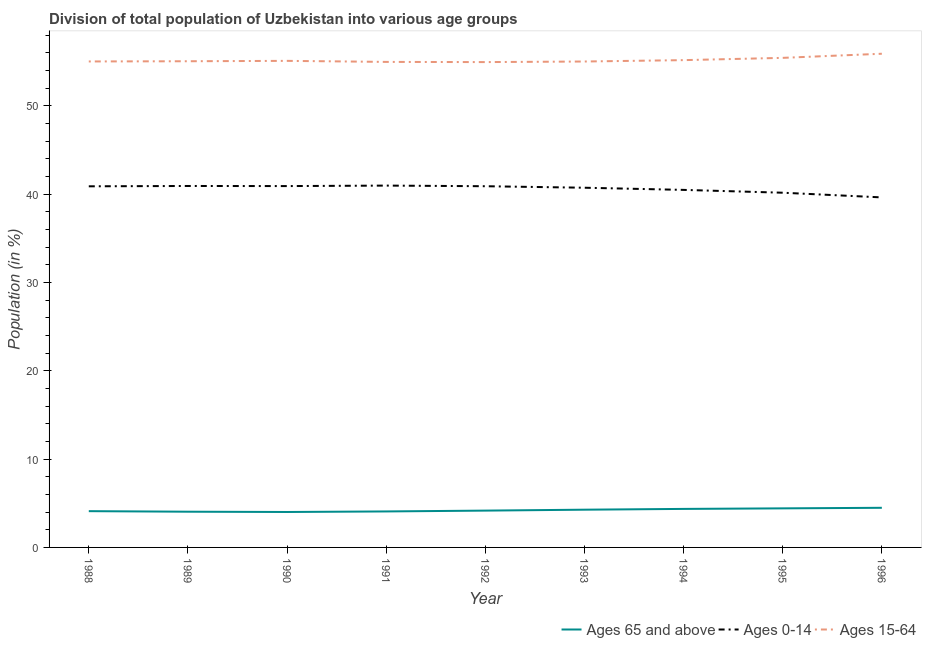Is the number of lines equal to the number of legend labels?
Make the answer very short. Yes. What is the percentage of population within the age-group 15-64 in 1994?
Give a very brief answer. 55.16. Across all years, what is the maximum percentage of population within the age-group of 65 and above?
Offer a very short reply. 4.49. Across all years, what is the minimum percentage of population within the age-group 15-64?
Your response must be concise. 54.94. What is the total percentage of population within the age-group of 65 and above in the graph?
Make the answer very short. 37.95. What is the difference between the percentage of population within the age-group of 65 and above in 1993 and that in 1995?
Offer a very short reply. -0.15. What is the difference between the percentage of population within the age-group 0-14 in 1994 and the percentage of population within the age-group of 65 and above in 1993?
Make the answer very short. 36.2. What is the average percentage of population within the age-group 0-14 per year?
Provide a succinct answer. 40.61. In the year 1988, what is the difference between the percentage of population within the age-group 0-14 and percentage of population within the age-group of 65 and above?
Ensure brevity in your answer.  36.77. What is the ratio of the percentage of population within the age-group 15-64 in 1990 to that in 1992?
Your response must be concise. 1. Is the percentage of population within the age-group 15-64 in 1992 less than that in 1995?
Your response must be concise. Yes. Is the difference between the percentage of population within the age-group 0-14 in 1989 and 1990 greater than the difference between the percentage of population within the age-group 15-64 in 1989 and 1990?
Your answer should be very brief. Yes. What is the difference between the highest and the second highest percentage of population within the age-group 15-64?
Give a very brief answer. 0.47. What is the difference between the highest and the lowest percentage of population within the age-group of 65 and above?
Keep it short and to the point. 0.48. In how many years, is the percentage of population within the age-group 0-14 greater than the average percentage of population within the age-group 0-14 taken over all years?
Keep it short and to the point. 6. Is the sum of the percentage of population within the age-group 0-14 in 1988 and 1990 greater than the maximum percentage of population within the age-group 15-64 across all years?
Your answer should be very brief. Yes. Does the percentage of population within the age-group 15-64 monotonically increase over the years?
Provide a short and direct response. No. Is the percentage of population within the age-group 15-64 strictly less than the percentage of population within the age-group 0-14 over the years?
Your response must be concise. No. How many years are there in the graph?
Offer a terse response. 9. What is the difference between two consecutive major ticks on the Y-axis?
Make the answer very short. 10. Are the values on the major ticks of Y-axis written in scientific E-notation?
Offer a terse response. No. Does the graph contain grids?
Your answer should be compact. No. Where does the legend appear in the graph?
Offer a very short reply. Bottom right. How many legend labels are there?
Keep it short and to the point. 3. How are the legend labels stacked?
Give a very brief answer. Horizontal. What is the title of the graph?
Ensure brevity in your answer.  Division of total population of Uzbekistan into various age groups
. What is the Population (in %) in Ages 65 and above in 1988?
Your answer should be compact. 4.11. What is the Population (in %) of Ages 0-14 in 1988?
Offer a terse response. 40.88. What is the Population (in %) in Ages 15-64 in 1988?
Your response must be concise. 55.01. What is the Population (in %) of Ages 65 and above in 1989?
Give a very brief answer. 4.04. What is the Population (in %) in Ages 0-14 in 1989?
Give a very brief answer. 40.92. What is the Population (in %) of Ages 15-64 in 1989?
Provide a succinct answer. 55.04. What is the Population (in %) of Ages 65 and above in 1990?
Your response must be concise. 4.01. What is the Population (in %) in Ages 0-14 in 1990?
Give a very brief answer. 40.91. What is the Population (in %) in Ages 15-64 in 1990?
Your response must be concise. 55.08. What is the Population (in %) of Ages 65 and above in 1991?
Your answer should be compact. 4.07. What is the Population (in %) of Ages 0-14 in 1991?
Keep it short and to the point. 40.96. What is the Population (in %) of Ages 15-64 in 1991?
Provide a short and direct response. 54.96. What is the Population (in %) of Ages 65 and above in 1992?
Offer a very short reply. 4.17. What is the Population (in %) in Ages 0-14 in 1992?
Make the answer very short. 40.89. What is the Population (in %) of Ages 15-64 in 1992?
Provide a succinct answer. 54.94. What is the Population (in %) in Ages 65 and above in 1993?
Offer a terse response. 4.27. What is the Population (in %) in Ages 0-14 in 1993?
Your answer should be compact. 40.72. What is the Population (in %) of Ages 15-64 in 1993?
Offer a very short reply. 55.01. What is the Population (in %) in Ages 65 and above in 1994?
Keep it short and to the point. 4.36. What is the Population (in %) of Ages 0-14 in 1994?
Your answer should be compact. 40.47. What is the Population (in %) in Ages 15-64 in 1994?
Keep it short and to the point. 55.16. What is the Population (in %) of Ages 65 and above in 1995?
Your answer should be compact. 4.42. What is the Population (in %) in Ages 0-14 in 1995?
Ensure brevity in your answer.  40.16. What is the Population (in %) of Ages 15-64 in 1995?
Provide a succinct answer. 55.42. What is the Population (in %) in Ages 65 and above in 1996?
Give a very brief answer. 4.49. What is the Population (in %) in Ages 0-14 in 1996?
Offer a very short reply. 39.62. What is the Population (in %) in Ages 15-64 in 1996?
Keep it short and to the point. 55.89. Across all years, what is the maximum Population (in %) of Ages 65 and above?
Your answer should be compact. 4.49. Across all years, what is the maximum Population (in %) in Ages 0-14?
Your response must be concise. 40.96. Across all years, what is the maximum Population (in %) in Ages 15-64?
Offer a terse response. 55.89. Across all years, what is the minimum Population (in %) of Ages 65 and above?
Keep it short and to the point. 4.01. Across all years, what is the minimum Population (in %) in Ages 0-14?
Offer a terse response. 39.62. Across all years, what is the minimum Population (in %) in Ages 15-64?
Your answer should be compact. 54.94. What is the total Population (in %) of Ages 65 and above in the graph?
Your answer should be compact. 37.95. What is the total Population (in %) of Ages 0-14 in the graph?
Keep it short and to the point. 365.53. What is the total Population (in %) in Ages 15-64 in the graph?
Give a very brief answer. 496.52. What is the difference between the Population (in %) in Ages 65 and above in 1988 and that in 1989?
Ensure brevity in your answer.  0.06. What is the difference between the Population (in %) in Ages 0-14 in 1988 and that in 1989?
Offer a terse response. -0.04. What is the difference between the Population (in %) in Ages 15-64 in 1988 and that in 1989?
Keep it short and to the point. -0.02. What is the difference between the Population (in %) of Ages 65 and above in 1988 and that in 1990?
Your answer should be compact. 0.09. What is the difference between the Population (in %) in Ages 0-14 in 1988 and that in 1990?
Make the answer very short. -0.03. What is the difference between the Population (in %) of Ages 15-64 in 1988 and that in 1990?
Keep it short and to the point. -0.07. What is the difference between the Population (in %) in Ages 65 and above in 1988 and that in 1991?
Provide a succinct answer. 0.03. What is the difference between the Population (in %) in Ages 0-14 in 1988 and that in 1991?
Make the answer very short. -0.08. What is the difference between the Population (in %) in Ages 15-64 in 1988 and that in 1991?
Keep it short and to the point. 0.05. What is the difference between the Population (in %) in Ages 65 and above in 1988 and that in 1992?
Ensure brevity in your answer.  -0.06. What is the difference between the Population (in %) of Ages 0-14 in 1988 and that in 1992?
Keep it short and to the point. -0.01. What is the difference between the Population (in %) of Ages 15-64 in 1988 and that in 1992?
Provide a succinct answer. 0.07. What is the difference between the Population (in %) in Ages 65 and above in 1988 and that in 1993?
Keep it short and to the point. -0.17. What is the difference between the Population (in %) of Ages 0-14 in 1988 and that in 1993?
Ensure brevity in your answer.  0.16. What is the difference between the Population (in %) in Ages 15-64 in 1988 and that in 1993?
Provide a succinct answer. 0.01. What is the difference between the Population (in %) in Ages 65 and above in 1988 and that in 1994?
Offer a very short reply. -0.26. What is the difference between the Population (in %) of Ages 0-14 in 1988 and that in 1994?
Make the answer very short. 0.41. What is the difference between the Population (in %) of Ages 15-64 in 1988 and that in 1994?
Keep it short and to the point. -0.15. What is the difference between the Population (in %) in Ages 65 and above in 1988 and that in 1995?
Your answer should be very brief. -0.32. What is the difference between the Population (in %) of Ages 0-14 in 1988 and that in 1995?
Make the answer very short. 0.73. What is the difference between the Population (in %) of Ages 15-64 in 1988 and that in 1995?
Make the answer very short. -0.41. What is the difference between the Population (in %) of Ages 65 and above in 1988 and that in 1996?
Offer a very short reply. -0.38. What is the difference between the Population (in %) of Ages 0-14 in 1988 and that in 1996?
Provide a succinct answer. 1.26. What is the difference between the Population (in %) of Ages 15-64 in 1988 and that in 1996?
Ensure brevity in your answer.  -0.87. What is the difference between the Population (in %) of Ages 65 and above in 1989 and that in 1990?
Ensure brevity in your answer.  0.03. What is the difference between the Population (in %) in Ages 0-14 in 1989 and that in 1990?
Provide a short and direct response. 0.01. What is the difference between the Population (in %) in Ages 15-64 in 1989 and that in 1990?
Keep it short and to the point. -0.04. What is the difference between the Population (in %) in Ages 65 and above in 1989 and that in 1991?
Make the answer very short. -0.03. What is the difference between the Population (in %) in Ages 0-14 in 1989 and that in 1991?
Keep it short and to the point. -0.04. What is the difference between the Population (in %) of Ages 15-64 in 1989 and that in 1991?
Keep it short and to the point. 0.07. What is the difference between the Population (in %) in Ages 65 and above in 1989 and that in 1992?
Provide a succinct answer. -0.12. What is the difference between the Population (in %) of Ages 0-14 in 1989 and that in 1992?
Make the answer very short. 0.03. What is the difference between the Population (in %) of Ages 15-64 in 1989 and that in 1992?
Provide a short and direct response. 0.1. What is the difference between the Population (in %) in Ages 65 and above in 1989 and that in 1993?
Keep it short and to the point. -0.23. What is the difference between the Population (in %) of Ages 0-14 in 1989 and that in 1993?
Offer a very short reply. 0.2. What is the difference between the Population (in %) of Ages 15-64 in 1989 and that in 1993?
Your answer should be compact. 0.03. What is the difference between the Population (in %) in Ages 65 and above in 1989 and that in 1994?
Provide a short and direct response. -0.32. What is the difference between the Population (in %) in Ages 0-14 in 1989 and that in 1994?
Give a very brief answer. 0.44. What is the difference between the Population (in %) of Ages 15-64 in 1989 and that in 1994?
Your answer should be very brief. -0.13. What is the difference between the Population (in %) in Ages 65 and above in 1989 and that in 1995?
Keep it short and to the point. -0.38. What is the difference between the Population (in %) of Ages 0-14 in 1989 and that in 1995?
Provide a succinct answer. 0.76. What is the difference between the Population (in %) in Ages 15-64 in 1989 and that in 1995?
Give a very brief answer. -0.38. What is the difference between the Population (in %) of Ages 65 and above in 1989 and that in 1996?
Your answer should be compact. -0.44. What is the difference between the Population (in %) of Ages 0-14 in 1989 and that in 1996?
Your response must be concise. 1.29. What is the difference between the Population (in %) in Ages 15-64 in 1989 and that in 1996?
Make the answer very short. -0.85. What is the difference between the Population (in %) of Ages 65 and above in 1990 and that in 1991?
Offer a terse response. -0.06. What is the difference between the Population (in %) of Ages 0-14 in 1990 and that in 1991?
Offer a terse response. -0.06. What is the difference between the Population (in %) of Ages 15-64 in 1990 and that in 1991?
Your answer should be very brief. 0.12. What is the difference between the Population (in %) in Ages 65 and above in 1990 and that in 1992?
Offer a terse response. -0.16. What is the difference between the Population (in %) of Ages 0-14 in 1990 and that in 1992?
Provide a short and direct response. 0.02. What is the difference between the Population (in %) of Ages 15-64 in 1990 and that in 1992?
Make the answer very short. 0.14. What is the difference between the Population (in %) in Ages 65 and above in 1990 and that in 1993?
Your response must be concise. -0.26. What is the difference between the Population (in %) of Ages 0-14 in 1990 and that in 1993?
Provide a short and direct response. 0.19. What is the difference between the Population (in %) of Ages 15-64 in 1990 and that in 1993?
Your response must be concise. 0.07. What is the difference between the Population (in %) in Ages 65 and above in 1990 and that in 1994?
Ensure brevity in your answer.  -0.35. What is the difference between the Population (in %) in Ages 0-14 in 1990 and that in 1994?
Give a very brief answer. 0.43. What is the difference between the Population (in %) of Ages 15-64 in 1990 and that in 1994?
Ensure brevity in your answer.  -0.08. What is the difference between the Population (in %) of Ages 65 and above in 1990 and that in 1995?
Keep it short and to the point. -0.41. What is the difference between the Population (in %) of Ages 0-14 in 1990 and that in 1995?
Give a very brief answer. 0.75. What is the difference between the Population (in %) of Ages 15-64 in 1990 and that in 1995?
Ensure brevity in your answer.  -0.34. What is the difference between the Population (in %) of Ages 65 and above in 1990 and that in 1996?
Provide a succinct answer. -0.48. What is the difference between the Population (in %) of Ages 0-14 in 1990 and that in 1996?
Keep it short and to the point. 1.28. What is the difference between the Population (in %) in Ages 15-64 in 1990 and that in 1996?
Provide a short and direct response. -0.81. What is the difference between the Population (in %) of Ages 65 and above in 1991 and that in 1992?
Your answer should be compact. -0.09. What is the difference between the Population (in %) of Ages 0-14 in 1991 and that in 1992?
Your answer should be compact. 0.07. What is the difference between the Population (in %) in Ages 15-64 in 1991 and that in 1992?
Your response must be concise. 0.02. What is the difference between the Population (in %) of Ages 65 and above in 1991 and that in 1993?
Offer a very short reply. -0.2. What is the difference between the Population (in %) in Ages 0-14 in 1991 and that in 1993?
Your answer should be very brief. 0.24. What is the difference between the Population (in %) of Ages 15-64 in 1991 and that in 1993?
Provide a succinct answer. -0.05. What is the difference between the Population (in %) in Ages 65 and above in 1991 and that in 1994?
Your answer should be compact. -0.29. What is the difference between the Population (in %) of Ages 0-14 in 1991 and that in 1994?
Ensure brevity in your answer.  0.49. What is the difference between the Population (in %) in Ages 15-64 in 1991 and that in 1994?
Offer a terse response. -0.2. What is the difference between the Population (in %) in Ages 65 and above in 1991 and that in 1995?
Ensure brevity in your answer.  -0.35. What is the difference between the Population (in %) in Ages 0-14 in 1991 and that in 1995?
Your response must be concise. 0.81. What is the difference between the Population (in %) in Ages 15-64 in 1991 and that in 1995?
Ensure brevity in your answer.  -0.46. What is the difference between the Population (in %) of Ages 65 and above in 1991 and that in 1996?
Ensure brevity in your answer.  -0.41. What is the difference between the Population (in %) in Ages 0-14 in 1991 and that in 1996?
Your response must be concise. 1.34. What is the difference between the Population (in %) of Ages 15-64 in 1991 and that in 1996?
Provide a succinct answer. -0.92. What is the difference between the Population (in %) of Ages 65 and above in 1992 and that in 1993?
Ensure brevity in your answer.  -0.1. What is the difference between the Population (in %) in Ages 0-14 in 1992 and that in 1993?
Your answer should be compact. 0.17. What is the difference between the Population (in %) in Ages 15-64 in 1992 and that in 1993?
Provide a succinct answer. -0.07. What is the difference between the Population (in %) in Ages 65 and above in 1992 and that in 1994?
Your response must be concise. -0.19. What is the difference between the Population (in %) of Ages 0-14 in 1992 and that in 1994?
Give a very brief answer. 0.42. What is the difference between the Population (in %) in Ages 15-64 in 1992 and that in 1994?
Keep it short and to the point. -0.22. What is the difference between the Population (in %) of Ages 65 and above in 1992 and that in 1995?
Make the answer very short. -0.26. What is the difference between the Population (in %) in Ages 0-14 in 1992 and that in 1995?
Ensure brevity in your answer.  0.73. What is the difference between the Population (in %) of Ages 15-64 in 1992 and that in 1995?
Your response must be concise. -0.48. What is the difference between the Population (in %) of Ages 65 and above in 1992 and that in 1996?
Offer a very short reply. -0.32. What is the difference between the Population (in %) in Ages 0-14 in 1992 and that in 1996?
Your answer should be very brief. 1.27. What is the difference between the Population (in %) in Ages 15-64 in 1992 and that in 1996?
Your answer should be compact. -0.95. What is the difference between the Population (in %) of Ages 65 and above in 1993 and that in 1994?
Provide a succinct answer. -0.09. What is the difference between the Population (in %) in Ages 0-14 in 1993 and that in 1994?
Ensure brevity in your answer.  0.24. What is the difference between the Population (in %) of Ages 15-64 in 1993 and that in 1994?
Offer a very short reply. -0.16. What is the difference between the Population (in %) of Ages 65 and above in 1993 and that in 1995?
Make the answer very short. -0.15. What is the difference between the Population (in %) in Ages 0-14 in 1993 and that in 1995?
Offer a terse response. 0.56. What is the difference between the Population (in %) in Ages 15-64 in 1993 and that in 1995?
Ensure brevity in your answer.  -0.41. What is the difference between the Population (in %) of Ages 65 and above in 1993 and that in 1996?
Make the answer very short. -0.22. What is the difference between the Population (in %) in Ages 0-14 in 1993 and that in 1996?
Give a very brief answer. 1.09. What is the difference between the Population (in %) of Ages 15-64 in 1993 and that in 1996?
Provide a succinct answer. -0.88. What is the difference between the Population (in %) in Ages 65 and above in 1994 and that in 1995?
Your response must be concise. -0.06. What is the difference between the Population (in %) of Ages 0-14 in 1994 and that in 1995?
Your answer should be compact. 0.32. What is the difference between the Population (in %) in Ages 15-64 in 1994 and that in 1995?
Your answer should be very brief. -0.26. What is the difference between the Population (in %) of Ages 65 and above in 1994 and that in 1996?
Your response must be concise. -0.13. What is the difference between the Population (in %) in Ages 0-14 in 1994 and that in 1996?
Offer a terse response. 0.85. What is the difference between the Population (in %) of Ages 15-64 in 1994 and that in 1996?
Your response must be concise. -0.72. What is the difference between the Population (in %) of Ages 65 and above in 1995 and that in 1996?
Your answer should be compact. -0.06. What is the difference between the Population (in %) in Ages 0-14 in 1995 and that in 1996?
Provide a succinct answer. 0.53. What is the difference between the Population (in %) in Ages 15-64 in 1995 and that in 1996?
Your answer should be compact. -0.47. What is the difference between the Population (in %) in Ages 65 and above in 1988 and the Population (in %) in Ages 0-14 in 1989?
Your answer should be very brief. -36.81. What is the difference between the Population (in %) in Ages 65 and above in 1988 and the Population (in %) in Ages 15-64 in 1989?
Your answer should be compact. -50.93. What is the difference between the Population (in %) of Ages 0-14 in 1988 and the Population (in %) of Ages 15-64 in 1989?
Make the answer very short. -14.16. What is the difference between the Population (in %) of Ages 65 and above in 1988 and the Population (in %) of Ages 0-14 in 1990?
Ensure brevity in your answer.  -36.8. What is the difference between the Population (in %) of Ages 65 and above in 1988 and the Population (in %) of Ages 15-64 in 1990?
Your answer should be very brief. -50.98. What is the difference between the Population (in %) in Ages 0-14 in 1988 and the Population (in %) in Ages 15-64 in 1990?
Your response must be concise. -14.2. What is the difference between the Population (in %) of Ages 65 and above in 1988 and the Population (in %) of Ages 0-14 in 1991?
Make the answer very short. -36.86. What is the difference between the Population (in %) of Ages 65 and above in 1988 and the Population (in %) of Ages 15-64 in 1991?
Your response must be concise. -50.86. What is the difference between the Population (in %) in Ages 0-14 in 1988 and the Population (in %) in Ages 15-64 in 1991?
Give a very brief answer. -14.08. What is the difference between the Population (in %) of Ages 65 and above in 1988 and the Population (in %) of Ages 0-14 in 1992?
Your response must be concise. -36.78. What is the difference between the Population (in %) of Ages 65 and above in 1988 and the Population (in %) of Ages 15-64 in 1992?
Make the answer very short. -50.84. What is the difference between the Population (in %) in Ages 0-14 in 1988 and the Population (in %) in Ages 15-64 in 1992?
Ensure brevity in your answer.  -14.06. What is the difference between the Population (in %) of Ages 65 and above in 1988 and the Population (in %) of Ages 0-14 in 1993?
Your answer should be compact. -36.61. What is the difference between the Population (in %) in Ages 65 and above in 1988 and the Population (in %) in Ages 15-64 in 1993?
Offer a terse response. -50.9. What is the difference between the Population (in %) in Ages 0-14 in 1988 and the Population (in %) in Ages 15-64 in 1993?
Give a very brief answer. -14.13. What is the difference between the Population (in %) of Ages 65 and above in 1988 and the Population (in %) of Ages 0-14 in 1994?
Provide a succinct answer. -36.37. What is the difference between the Population (in %) in Ages 65 and above in 1988 and the Population (in %) in Ages 15-64 in 1994?
Ensure brevity in your answer.  -51.06. What is the difference between the Population (in %) of Ages 0-14 in 1988 and the Population (in %) of Ages 15-64 in 1994?
Make the answer very short. -14.28. What is the difference between the Population (in %) of Ages 65 and above in 1988 and the Population (in %) of Ages 0-14 in 1995?
Your answer should be compact. -36.05. What is the difference between the Population (in %) of Ages 65 and above in 1988 and the Population (in %) of Ages 15-64 in 1995?
Ensure brevity in your answer.  -51.32. What is the difference between the Population (in %) of Ages 0-14 in 1988 and the Population (in %) of Ages 15-64 in 1995?
Offer a terse response. -14.54. What is the difference between the Population (in %) in Ages 65 and above in 1988 and the Population (in %) in Ages 0-14 in 1996?
Your answer should be very brief. -35.52. What is the difference between the Population (in %) of Ages 65 and above in 1988 and the Population (in %) of Ages 15-64 in 1996?
Offer a very short reply. -51.78. What is the difference between the Population (in %) in Ages 0-14 in 1988 and the Population (in %) in Ages 15-64 in 1996?
Your answer should be very brief. -15.01. What is the difference between the Population (in %) in Ages 65 and above in 1989 and the Population (in %) in Ages 0-14 in 1990?
Ensure brevity in your answer.  -36.86. What is the difference between the Population (in %) in Ages 65 and above in 1989 and the Population (in %) in Ages 15-64 in 1990?
Provide a short and direct response. -51.04. What is the difference between the Population (in %) of Ages 0-14 in 1989 and the Population (in %) of Ages 15-64 in 1990?
Provide a succinct answer. -14.16. What is the difference between the Population (in %) of Ages 65 and above in 1989 and the Population (in %) of Ages 0-14 in 1991?
Give a very brief answer. -36.92. What is the difference between the Population (in %) in Ages 65 and above in 1989 and the Population (in %) in Ages 15-64 in 1991?
Give a very brief answer. -50.92. What is the difference between the Population (in %) in Ages 0-14 in 1989 and the Population (in %) in Ages 15-64 in 1991?
Keep it short and to the point. -14.05. What is the difference between the Population (in %) in Ages 65 and above in 1989 and the Population (in %) in Ages 0-14 in 1992?
Provide a short and direct response. -36.85. What is the difference between the Population (in %) of Ages 65 and above in 1989 and the Population (in %) of Ages 15-64 in 1992?
Your response must be concise. -50.9. What is the difference between the Population (in %) in Ages 0-14 in 1989 and the Population (in %) in Ages 15-64 in 1992?
Offer a terse response. -14.02. What is the difference between the Population (in %) of Ages 65 and above in 1989 and the Population (in %) of Ages 0-14 in 1993?
Your answer should be compact. -36.68. What is the difference between the Population (in %) in Ages 65 and above in 1989 and the Population (in %) in Ages 15-64 in 1993?
Keep it short and to the point. -50.97. What is the difference between the Population (in %) of Ages 0-14 in 1989 and the Population (in %) of Ages 15-64 in 1993?
Offer a terse response. -14.09. What is the difference between the Population (in %) in Ages 65 and above in 1989 and the Population (in %) in Ages 0-14 in 1994?
Provide a short and direct response. -36.43. What is the difference between the Population (in %) in Ages 65 and above in 1989 and the Population (in %) in Ages 15-64 in 1994?
Keep it short and to the point. -51.12. What is the difference between the Population (in %) of Ages 0-14 in 1989 and the Population (in %) of Ages 15-64 in 1994?
Keep it short and to the point. -14.25. What is the difference between the Population (in %) of Ages 65 and above in 1989 and the Population (in %) of Ages 0-14 in 1995?
Provide a succinct answer. -36.11. What is the difference between the Population (in %) in Ages 65 and above in 1989 and the Population (in %) in Ages 15-64 in 1995?
Give a very brief answer. -51.38. What is the difference between the Population (in %) in Ages 0-14 in 1989 and the Population (in %) in Ages 15-64 in 1995?
Keep it short and to the point. -14.5. What is the difference between the Population (in %) of Ages 65 and above in 1989 and the Population (in %) of Ages 0-14 in 1996?
Your answer should be compact. -35.58. What is the difference between the Population (in %) of Ages 65 and above in 1989 and the Population (in %) of Ages 15-64 in 1996?
Keep it short and to the point. -51.84. What is the difference between the Population (in %) in Ages 0-14 in 1989 and the Population (in %) in Ages 15-64 in 1996?
Provide a succinct answer. -14.97. What is the difference between the Population (in %) of Ages 65 and above in 1990 and the Population (in %) of Ages 0-14 in 1991?
Provide a succinct answer. -36.95. What is the difference between the Population (in %) of Ages 65 and above in 1990 and the Population (in %) of Ages 15-64 in 1991?
Keep it short and to the point. -50.95. What is the difference between the Population (in %) in Ages 0-14 in 1990 and the Population (in %) in Ages 15-64 in 1991?
Give a very brief answer. -14.06. What is the difference between the Population (in %) of Ages 65 and above in 1990 and the Population (in %) of Ages 0-14 in 1992?
Keep it short and to the point. -36.88. What is the difference between the Population (in %) of Ages 65 and above in 1990 and the Population (in %) of Ages 15-64 in 1992?
Give a very brief answer. -50.93. What is the difference between the Population (in %) of Ages 0-14 in 1990 and the Population (in %) of Ages 15-64 in 1992?
Your response must be concise. -14.04. What is the difference between the Population (in %) in Ages 65 and above in 1990 and the Population (in %) in Ages 0-14 in 1993?
Keep it short and to the point. -36.71. What is the difference between the Population (in %) of Ages 65 and above in 1990 and the Population (in %) of Ages 15-64 in 1993?
Your response must be concise. -51. What is the difference between the Population (in %) of Ages 0-14 in 1990 and the Population (in %) of Ages 15-64 in 1993?
Your response must be concise. -14.1. What is the difference between the Population (in %) of Ages 65 and above in 1990 and the Population (in %) of Ages 0-14 in 1994?
Keep it short and to the point. -36.46. What is the difference between the Population (in %) of Ages 65 and above in 1990 and the Population (in %) of Ages 15-64 in 1994?
Make the answer very short. -51.15. What is the difference between the Population (in %) of Ages 0-14 in 1990 and the Population (in %) of Ages 15-64 in 1994?
Keep it short and to the point. -14.26. What is the difference between the Population (in %) of Ages 65 and above in 1990 and the Population (in %) of Ages 0-14 in 1995?
Your answer should be very brief. -36.14. What is the difference between the Population (in %) of Ages 65 and above in 1990 and the Population (in %) of Ages 15-64 in 1995?
Ensure brevity in your answer.  -51.41. What is the difference between the Population (in %) of Ages 0-14 in 1990 and the Population (in %) of Ages 15-64 in 1995?
Provide a short and direct response. -14.52. What is the difference between the Population (in %) of Ages 65 and above in 1990 and the Population (in %) of Ages 0-14 in 1996?
Your answer should be compact. -35.61. What is the difference between the Population (in %) of Ages 65 and above in 1990 and the Population (in %) of Ages 15-64 in 1996?
Your answer should be compact. -51.88. What is the difference between the Population (in %) of Ages 0-14 in 1990 and the Population (in %) of Ages 15-64 in 1996?
Provide a succinct answer. -14.98. What is the difference between the Population (in %) in Ages 65 and above in 1991 and the Population (in %) in Ages 0-14 in 1992?
Provide a short and direct response. -36.82. What is the difference between the Population (in %) in Ages 65 and above in 1991 and the Population (in %) in Ages 15-64 in 1992?
Keep it short and to the point. -50.87. What is the difference between the Population (in %) of Ages 0-14 in 1991 and the Population (in %) of Ages 15-64 in 1992?
Keep it short and to the point. -13.98. What is the difference between the Population (in %) of Ages 65 and above in 1991 and the Population (in %) of Ages 0-14 in 1993?
Give a very brief answer. -36.65. What is the difference between the Population (in %) in Ages 65 and above in 1991 and the Population (in %) in Ages 15-64 in 1993?
Keep it short and to the point. -50.93. What is the difference between the Population (in %) in Ages 0-14 in 1991 and the Population (in %) in Ages 15-64 in 1993?
Offer a very short reply. -14.05. What is the difference between the Population (in %) of Ages 65 and above in 1991 and the Population (in %) of Ages 0-14 in 1994?
Offer a very short reply. -36.4. What is the difference between the Population (in %) of Ages 65 and above in 1991 and the Population (in %) of Ages 15-64 in 1994?
Keep it short and to the point. -51.09. What is the difference between the Population (in %) in Ages 0-14 in 1991 and the Population (in %) in Ages 15-64 in 1994?
Keep it short and to the point. -14.2. What is the difference between the Population (in %) of Ages 65 and above in 1991 and the Population (in %) of Ages 0-14 in 1995?
Provide a short and direct response. -36.08. What is the difference between the Population (in %) in Ages 65 and above in 1991 and the Population (in %) in Ages 15-64 in 1995?
Provide a short and direct response. -51.35. What is the difference between the Population (in %) in Ages 0-14 in 1991 and the Population (in %) in Ages 15-64 in 1995?
Your answer should be very brief. -14.46. What is the difference between the Population (in %) in Ages 65 and above in 1991 and the Population (in %) in Ages 0-14 in 1996?
Offer a terse response. -35.55. What is the difference between the Population (in %) of Ages 65 and above in 1991 and the Population (in %) of Ages 15-64 in 1996?
Provide a short and direct response. -51.81. What is the difference between the Population (in %) in Ages 0-14 in 1991 and the Population (in %) in Ages 15-64 in 1996?
Make the answer very short. -14.93. What is the difference between the Population (in %) in Ages 65 and above in 1992 and the Population (in %) in Ages 0-14 in 1993?
Make the answer very short. -36.55. What is the difference between the Population (in %) of Ages 65 and above in 1992 and the Population (in %) of Ages 15-64 in 1993?
Offer a very short reply. -50.84. What is the difference between the Population (in %) in Ages 0-14 in 1992 and the Population (in %) in Ages 15-64 in 1993?
Keep it short and to the point. -14.12. What is the difference between the Population (in %) of Ages 65 and above in 1992 and the Population (in %) of Ages 0-14 in 1994?
Your answer should be very brief. -36.31. What is the difference between the Population (in %) in Ages 65 and above in 1992 and the Population (in %) in Ages 15-64 in 1994?
Provide a short and direct response. -51. What is the difference between the Population (in %) of Ages 0-14 in 1992 and the Population (in %) of Ages 15-64 in 1994?
Your answer should be compact. -14.27. What is the difference between the Population (in %) in Ages 65 and above in 1992 and the Population (in %) in Ages 0-14 in 1995?
Make the answer very short. -35.99. What is the difference between the Population (in %) of Ages 65 and above in 1992 and the Population (in %) of Ages 15-64 in 1995?
Ensure brevity in your answer.  -51.25. What is the difference between the Population (in %) of Ages 0-14 in 1992 and the Population (in %) of Ages 15-64 in 1995?
Give a very brief answer. -14.53. What is the difference between the Population (in %) of Ages 65 and above in 1992 and the Population (in %) of Ages 0-14 in 1996?
Your answer should be compact. -35.46. What is the difference between the Population (in %) of Ages 65 and above in 1992 and the Population (in %) of Ages 15-64 in 1996?
Offer a very short reply. -51.72. What is the difference between the Population (in %) of Ages 0-14 in 1992 and the Population (in %) of Ages 15-64 in 1996?
Provide a succinct answer. -15. What is the difference between the Population (in %) of Ages 65 and above in 1993 and the Population (in %) of Ages 0-14 in 1994?
Your response must be concise. -36.2. What is the difference between the Population (in %) of Ages 65 and above in 1993 and the Population (in %) of Ages 15-64 in 1994?
Keep it short and to the point. -50.89. What is the difference between the Population (in %) of Ages 0-14 in 1993 and the Population (in %) of Ages 15-64 in 1994?
Make the answer very short. -14.44. What is the difference between the Population (in %) of Ages 65 and above in 1993 and the Population (in %) of Ages 0-14 in 1995?
Your response must be concise. -35.88. What is the difference between the Population (in %) of Ages 65 and above in 1993 and the Population (in %) of Ages 15-64 in 1995?
Your answer should be compact. -51.15. What is the difference between the Population (in %) in Ages 0-14 in 1993 and the Population (in %) in Ages 15-64 in 1995?
Ensure brevity in your answer.  -14.7. What is the difference between the Population (in %) of Ages 65 and above in 1993 and the Population (in %) of Ages 0-14 in 1996?
Provide a succinct answer. -35.35. What is the difference between the Population (in %) of Ages 65 and above in 1993 and the Population (in %) of Ages 15-64 in 1996?
Make the answer very short. -51.62. What is the difference between the Population (in %) in Ages 0-14 in 1993 and the Population (in %) in Ages 15-64 in 1996?
Provide a succinct answer. -15.17. What is the difference between the Population (in %) of Ages 65 and above in 1994 and the Population (in %) of Ages 0-14 in 1995?
Give a very brief answer. -35.79. What is the difference between the Population (in %) in Ages 65 and above in 1994 and the Population (in %) in Ages 15-64 in 1995?
Your answer should be compact. -51.06. What is the difference between the Population (in %) of Ages 0-14 in 1994 and the Population (in %) of Ages 15-64 in 1995?
Provide a succinct answer. -14.95. What is the difference between the Population (in %) of Ages 65 and above in 1994 and the Population (in %) of Ages 0-14 in 1996?
Offer a terse response. -35.26. What is the difference between the Population (in %) of Ages 65 and above in 1994 and the Population (in %) of Ages 15-64 in 1996?
Provide a succinct answer. -51.53. What is the difference between the Population (in %) in Ages 0-14 in 1994 and the Population (in %) in Ages 15-64 in 1996?
Give a very brief answer. -15.41. What is the difference between the Population (in %) of Ages 65 and above in 1995 and the Population (in %) of Ages 0-14 in 1996?
Offer a very short reply. -35.2. What is the difference between the Population (in %) of Ages 65 and above in 1995 and the Population (in %) of Ages 15-64 in 1996?
Your response must be concise. -51.46. What is the difference between the Population (in %) of Ages 0-14 in 1995 and the Population (in %) of Ages 15-64 in 1996?
Offer a very short reply. -15.73. What is the average Population (in %) in Ages 65 and above per year?
Provide a succinct answer. 4.22. What is the average Population (in %) of Ages 0-14 per year?
Make the answer very short. 40.61. What is the average Population (in %) in Ages 15-64 per year?
Your response must be concise. 55.17. In the year 1988, what is the difference between the Population (in %) of Ages 65 and above and Population (in %) of Ages 0-14?
Your answer should be compact. -36.77. In the year 1988, what is the difference between the Population (in %) of Ages 65 and above and Population (in %) of Ages 15-64?
Keep it short and to the point. -50.91. In the year 1988, what is the difference between the Population (in %) in Ages 0-14 and Population (in %) in Ages 15-64?
Keep it short and to the point. -14.13. In the year 1989, what is the difference between the Population (in %) in Ages 65 and above and Population (in %) in Ages 0-14?
Provide a short and direct response. -36.87. In the year 1989, what is the difference between the Population (in %) in Ages 65 and above and Population (in %) in Ages 15-64?
Offer a terse response. -50.99. In the year 1989, what is the difference between the Population (in %) of Ages 0-14 and Population (in %) of Ages 15-64?
Your answer should be very brief. -14.12. In the year 1990, what is the difference between the Population (in %) of Ages 65 and above and Population (in %) of Ages 0-14?
Offer a terse response. -36.9. In the year 1990, what is the difference between the Population (in %) of Ages 65 and above and Population (in %) of Ages 15-64?
Provide a short and direct response. -51.07. In the year 1990, what is the difference between the Population (in %) in Ages 0-14 and Population (in %) in Ages 15-64?
Your response must be concise. -14.18. In the year 1991, what is the difference between the Population (in %) of Ages 65 and above and Population (in %) of Ages 0-14?
Your answer should be compact. -36.89. In the year 1991, what is the difference between the Population (in %) in Ages 65 and above and Population (in %) in Ages 15-64?
Make the answer very short. -50.89. In the year 1991, what is the difference between the Population (in %) in Ages 0-14 and Population (in %) in Ages 15-64?
Your answer should be compact. -14. In the year 1992, what is the difference between the Population (in %) of Ages 65 and above and Population (in %) of Ages 0-14?
Offer a very short reply. -36.72. In the year 1992, what is the difference between the Population (in %) in Ages 65 and above and Population (in %) in Ages 15-64?
Offer a terse response. -50.77. In the year 1992, what is the difference between the Population (in %) of Ages 0-14 and Population (in %) of Ages 15-64?
Provide a succinct answer. -14.05. In the year 1993, what is the difference between the Population (in %) in Ages 65 and above and Population (in %) in Ages 0-14?
Make the answer very short. -36.45. In the year 1993, what is the difference between the Population (in %) of Ages 65 and above and Population (in %) of Ages 15-64?
Your response must be concise. -50.74. In the year 1993, what is the difference between the Population (in %) of Ages 0-14 and Population (in %) of Ages 15-64?
Provide a short and direct response. -14.29. In the year 1994, what is the difference between the Population (in %) in Ages 65 and above and Population (in %) in Ages 0-14?
Make the answer very short. -36.11. In the year 1994, what is the difference between the Population (in %) in Ages 65 and above and Population (in %) in Ages 15-64?
Provide a short and direct response. -50.8. In the year 1994, what is the difference between the Population (in %) of Ages 0-14 and Population (in %) of Ages 15-64?
Provide a short and direct response. -14.69. In the year 1995, what is the difference between the Population (in %) in Ages 65 and above and Population (in %) in Ages 0-14?
Your response must be concise. -35.73. In the year 1995, what is the difference between the Population (in %) in Ages 65 and above and Population (in %) in Ages 15-64?
Keep it short and to the point. -51. In the year 1995, what is the difference between the Population (in %) in Ages 0-14 and Population (in %) in Ages 15-64?
Make the answer very short. -15.27. In the year 1996, what is the difference between the Population (in %) of Ages 65 and above and Population (in %) of Ages 0-14?
Your answer should be compact. -35.14. In the year 1996, what is the difference between the Population (in %) in Ages 65 and above and Population (in %) in Ages 15-64?
Keep it short and to the point. -51.4. In the year 1996, what is the difference between the Population (in %) of Ages 0-14 and Population (in %) of Ages 15-64?
Your answer should be compact. -16.26. What is the ratio of the Population (in %) in Ages 65 and above in 1988 to that in 1989?
Make the answer very short. 1.02. What is the ratio of the Population (in %) of Ages 0-14 in 1988 to that in 1989?
Provide a succinct answer. 1. What is the ratio of the Population (in %) in Ages 65 and above in 1988 to that in 1990?
Ensure brevity in your answer.  1.02. What is the ratio of the Population (in %) of Ages 15-64 in 1988 to that in 1990?
Give a very brief answer. 1. What is the ratio of the Population (in %) of Ages 65 and above in 1988 to that in 1991?
Give a very brief answer. 1.01. What is the ratio of the Population (in %) in Ages 0-14 in 1988 to that in 1991?
Your response must be concise. 1. What is the ratio of the Population (in %) in Ages 65 and above in 1988 to that in 1992?
Your response must be concise. 0.99. What is the ratio of the Population (in %) in Ages 15-64 in 1988 to that in 1992?
Make the answer very short. 1. What is the ratio of the Population (in %) of Ages 65 and above in 1988 to that in 1993?
Offer a very short reply. 0.96. What is the ratio of the Population (in %) in Ages 0-14 in 1988 to that in 1993?
Offer a very short reply. 1. What is the ratio of the Population (in %) in Ages 15-64 in 1988 to that in 1993?
Ensure brevity in your answer.  1. What is the ratio of the Population (in %) of Ages 65 and above in 1988 to that in 1994?
Your answer should be compact. 0.94. What is the ratio of the Population (in %) of Ages 0-14 in 1988 to that in 1994?
Your response must be concise. 1.01. What is the ratio of the Population (in %) in Ages 65 and above in 1988 to that in 1995?
Provide a succinct answer. 0.93. What is the ratio of the Population (in %) in Ages 0-14 in 1988 to that in 1995?
Make the answer very short. 1.02. What is the ratio of the Population (in %) of Ages 65 and above in 1988 to that in 1996?
Your answer should be very brief. 0.92. What is the ratio of the Population (in %) of Ages 0-14 in 1988 to that in 1996?
Keep it short and to the point. 1.03. What is the ratio of the Population (in %) of Ages 15-64 in 1988 to that in 1996?
Provide a succinct answer. 0.98. What is the ratio of the Population (in %) of Ages 0-14 in 1989 to that in 1991?
Provide a short and direct response. 1. What is the ratio of the Population (in %) of Ages 65 and above in 1989 to that in 1992?
Your answer should be very brief. 0.97. What is the ratio of the Population (in %) in Ages 15-64 in 1989 to that in 1992?
Keep it short and to the point. 1. What is the ratio of the Population (in %) in Ages 65 and above in 1989 to that in 1993?
Your answer should be compact. 0.95. What is the ratio of the Population (in %) in Ages 15-64 in 1989 to that in 1993?
Your answer should be compact. 1. What is the ratio of the Population (in %) of Ages 65 and above in 1989 to that in 1994?
Keep it short and to the point. 0.93. What is the ratio of the Population (in %) in Ages 0-14 in 1989 to that in 1994?
Offer a terse response. 1.01. What is the ratio of the Population (in %) of Ages 65 and above in 1989 to that in 1995?
Keep it short and to the point. 0.91. What is the ratio of the Population (in %) in Ages 15-64 in 1989 to that in 1995?
Provide a short and direct response. 0.99. What is the ratio of the Population (in %) of Ages 65 and above in 1989 to that in 1996?
Your answer should be very brief. 0.9. What is the ratio of the Population (in %) of Ages 0-14 in 1989 to that in 1996?
Make the answer very short. 1.03. What is the ratio of the Population (in %) of Ages 15-64 in 1989 to that in 1996?
Your answer should be very brief. 0.98. What is the ratio of the Population (in %) of Ages 65 and above in 1990 to that in 1991?
Offer a terse response. 0.98. What is the ratio of the Population (in %) in Ages 0-14 in 1990 to that in 1991?
Your answer should be very brief. 1. What is the ratio of the Population (in %) in Ages 15-64 in 1990 to that in 1991?
Offer a very short reply. 1. What is the ratio of the Population (in %) in Ages 65 and above in 1990 to that in 1992?
Provide a short and direct response. 0.96. What is the ratio of the Population (in %) of Ages 65 and above in 1990 to that in 1993?
Offer a very short reply. 0.94. What is the ratio of the Population (in %) of Ages 0-14 in 1990 to that in 1993?
Ensure brevity in your answer.  1. What is the ratio of the Population (in %) in Ages 65 and above in 1990 to that in 1994?
Your response must be concise. 0.92. What is the ratio of the Population (in %) of Ages 0-14 in 1990 to that in 1994?
Your answer should be compact. 1.01. What is the ratio of the Population (in %) in Ages 65 and above in 1990 to that in 1995?
Make the answer very short. 0.91. What is the ratio of the Population (in %) in Ages 0-14 in 1990 to that in 1995?
Provide a short and direct response. 1.02. What is the ratio of the Population (in %) of Ages 65 and above in 1990 to that in 1996?
Your answer should be very brief. 0.89. What is the ratio of the Population (in %) in Ages 0-14 in 1990 to that in 1996?
Offer a very short reply. 1.03. What is the ratio of the Population (in %) in Ages 15-64 in 1990 to that in 1996?
Ensure brevity in your answer.  0.99. What is the ratio of the Population (in %) in Ages 65 and above in 1991 to that in 1992?
Your answer should be compact. 0.98. What is the ratio of the Population (in %) of Ages 0-14 in 1991 to that in 1992?
Provide a short and direct response. 1. What is the ratio of the Population (in %) of Ages 15-64 in 1991 to that in 1992?
Provide a short and direct response. 1. What is the ratio of the Population (in %) in Ages 65 and above in 1991 to that in 1993?
Give a very brief answer. 0.95. What is the ratio of the Population (in %) of Ages 0-14 in 1991 to that in 1993?
Provide a short and direct response. 1.01. What is the ratio of the Population (in %) of Ages 15-64 in 1991 to that in 1993?
Keep it short and to the point. 1. What is the ratio of the Population (in %) of Ages 65 and above in 1991 to that in 1994?
Your answer should be very brief. 0.93. What is the ratio of the Population (in %) in Ages 65 and above in 1991 to that in 1995?
Ensure brevity in your answer.  0.92. What is the ratio of the Population (in %) in Ages 0-14 in 1991 to that in 1995?
Offer a terse response. 1.02. What is the ratio of the Population (in %) in Ages 15-64 in 1991 to that in 1995?
Provide a short and direct response. 0.99. What is the ratio of the Population (in %) of Ages 65 and above in 1991 to that in 1996?
Give a very brief answer. 0.91. What is the ratio of the Population (in %) in Ages 0-14 in 1991 to that in 1996?
Your answer should be very brief. 1.03. What is the ratio of the Population (in %) in Ages 15-64 in 1991 to that in 1996?
Ensure brevity in your answer.  0.98. What is the ratio of the Population (in %) in Ages 65 and above in 1992 to that in 1993?
Give a very brief answer. 0.98. What is the ratio of the Population (in %) of Ages 0-14 in 1992 to that in 1993?
Make the answer very short. 1. What is the ratio of the Population (in %) in Ages 15-64 in 1992 to that in 1993?
Offer a very short reply. 1. What is the ratio of the Population (in %) of Ages 65 and above in 1992 to that in 1994?
Give a very brief answer. 0.96. What is the ratio of the Population (in %) in Ages 0-14 in 1992 to that in 1994?
Ensure brevity in your answer.  1.01. What is the ratio of the Population (in %) in Ages 15-64 in 1992 to that in 1994?
Your answer should be very brief. 1. What is the ratio of the Population (in %) of Ages 65 and above in 1992 to that in 1995?
Your answer should be very brief. 0.94. What is the ratio of the Population (in %) of Ages 0-14 in 1992 to that in 1995?
Offer a very short reply. 1.02. What is the ratio of the Population (in %) in Ages 65 and above in 1992 to that in 1996?
Your response must be concise. 0.93. What is the ratio of the Population (in %) of Ages 0-14 in 1992 to that in 1996?
Ensure brevity in your answer.  1.03. What is the ratio of the Population (in %) in Ages 15-64 in 1992 to that in 1996?
Offer a terse response. 0.98. What is the ratio of the Population (in %) in Ages 65 and above in 1993 to that in 1994?
Keep it short and to the point. 0.98. What is the ratio of the Population (in %) of Ages 0-14 in 1993 to that in 1994?
Your response must be concise. 1.01. What is the ratio of the Population (in %) of Ages 15-64 in 1993 to that in 1994?
Offer a terse response. 1. What is the ratio of the Population (in %) of Ages 65 and above in 1993 to that in 1995?
Your answer should be very brief. 0.97. What is the ratio of the Population (in %) of Ages 0-14 in 1993 to that in 1995?
Provide a succinct answer. 1.01. What is the ratio of the Population (in %) of Ages 15-64 in 1993 to that in 1995?
Keep it short and to the point. 0.99. What is the ratio of the Population (in %) in Ages 65 and above in 1993 to that in 1996?
Provide a short and direct response. 0.95. What is the ratio of the Population (in %) in Ages 0-14 in 1993 to that in 1996?
Your response must be concise. 1.03. What is the ratio of the Population (in %) of Ages 15-64 in 1993 to that in 1996?
Your answer should be compact. 0.98. What is the ratio of the Population (in %) in Ages 0-14 in 1994 to that in 1995?
Make the answer very short. 1.01. What is the ratio of the Population (in %) of Ages 65 and above in 1994 to that in 1996?
Provide a succinct answer. 0.97. What is the ratio of the Population (in %) in Ages 0-14 in 1994 to that in 1996?
Provide a succinct answer. 1.02. What is the ratio of the Population (in %) in Ages 15-64 in 1994 to that in 1996?
Keep it short and to the point. 0.99. What is the ratio of the Population (in %) in Ages 65 and above in 1995 to that in 1996?
Provide a succinct answer. 0.99. What is the ratio of the Population (in %) of Ages 0-14 in 1995 to that in 1996?
Provide a succinct answer. 1.01. What is the ratio of the Population (in %) in Ages 15-64 in 1995 to that in 1996?
Give a very brief answer. 0.99. What is the difference between the highest and the second highest Population (in %) of Ages 65 and above?
Offer a very short reply. 0.06. What is the difference between the highest and the second highest Population (in %) in Ages 0-14?
Offer a terse response. 0.04. What is the difference between the highest and the second highest Population (in %) in Ages 15-64?
Make the answer very short. 0.47. What is the difference between the highest and the lowest Population (in %) in Ages 65 and above?
Provide a succinct answer. 0.48. What is the difference between the highest and the lowest Population (in %) of Ages 0-14?
Keep it short and to the point. 1.34. What is the difference between the highest and the lowest Population (in %) in Ages 15-64?
Offer a very short reply. 0.95. 